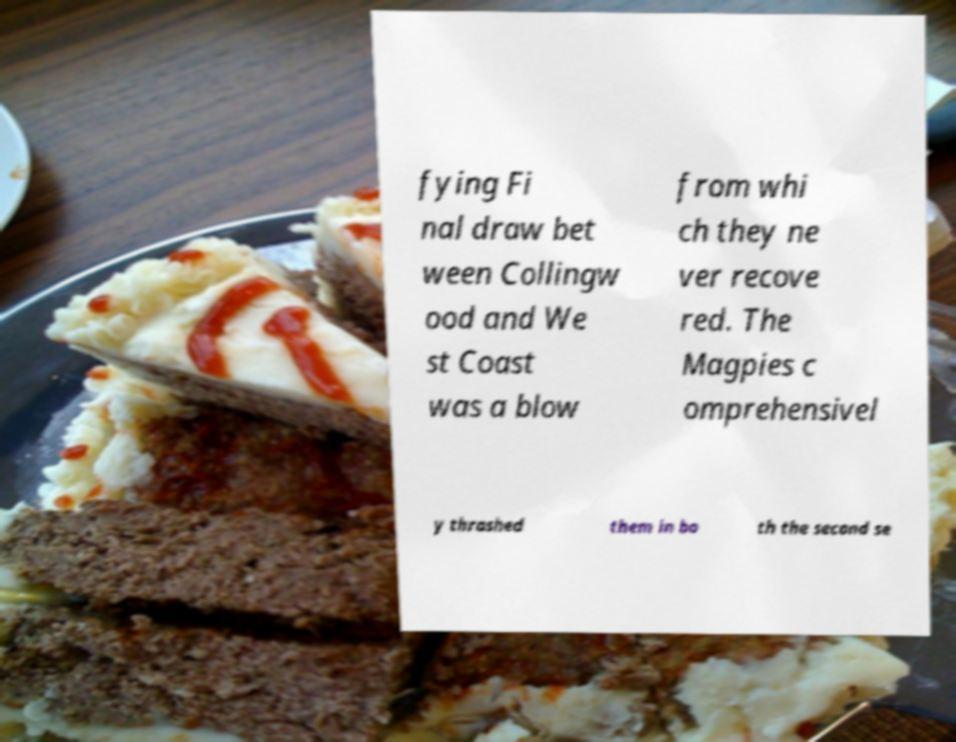Could you extract and type out the text from this image? fying Fi nal draw bet ween Collingw ood and We st Coast was a blow from whi ch they ne ver recove red. The Magpies c omprehensivel y thrashed them in bo th the second se 